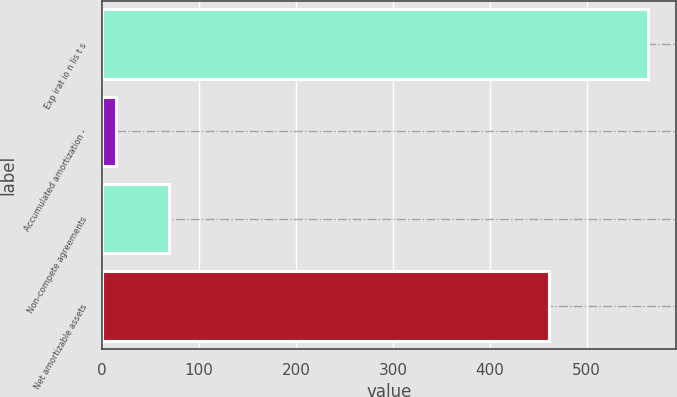Convert chart to OTSL. <chart><loc_0><loc_0><loc_500><loc_500><bar_chart><fcel>Exp irat io n lis t s<fcel>Accumulated amortization -<fcel>Non-compete agreements<fcel>Net amortizable assets<nl><fcel>563.7<fcel>14<fcel>68.97<fcel>461.2<nl></chart> 